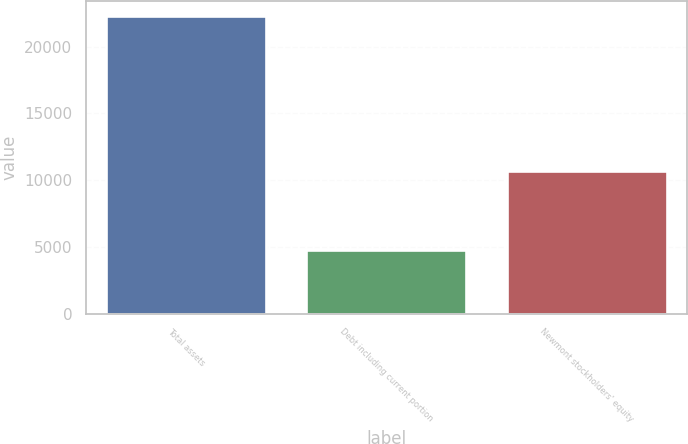Convert chart. <chart><loc_0><loc_0><loc_500><loc_500><bar_chart><fcel>Total assets<fcel>Debt including current portion<fcel>Newmont stockholders' equity<nl><fcel>22299<fcel>4809<fcel>10703<nl></chart> 